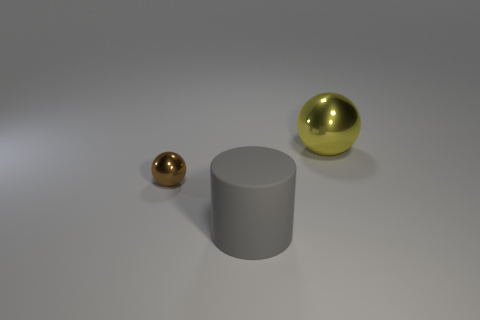What time of day does the lighting in the scene suggest? The lighting in the scene doesn't suggest a specific time of day. It appears to be a neutral, studio-like lighting setup typically used in 3D renderings, designed to highlight the objects without casting strong directional shadows. 